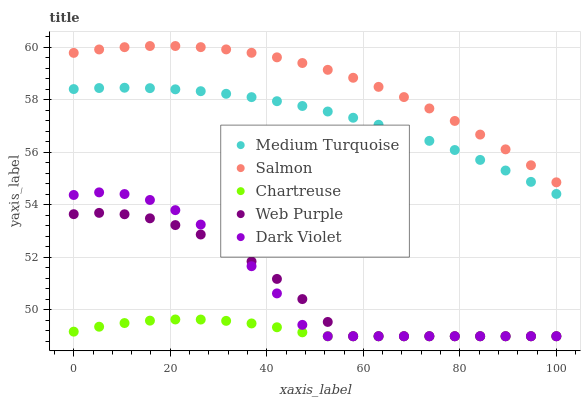Does Chartreuse have the minimum area under the curve?
Answer yes or no. Yes. Does Salmon have the maximum area under the curve?
Answer yes or no. Yes. Does Salmon have the minimum area under the curve?
Answer yes or no. No. Does Chartreuse have the maximum area under the curve?
Answer yes or no. No. Is Medium Turquoise the smoothest?
Answer yes or no. Yes. Is Dark Violet the roughest?
Answer yes or no. Yes. Is Chartreuse the smoothest?
Answer yes or no. No. Is Chartreuse the roughest?
Answer yes or no. No. Does Dark Violet have the lowest value?
Answer yes or no. Yes. Does Salmon have the lowest value?
Answer yes or no. No. Does Salmon have the highest value?
Answer yes or no. Yes. Does Chartreuse have the highest value?
Answer yes or no. No. Is Chartreuse less than Salmon?
Answer yes or no. Yes. Is Salmon greater than Web Purple?
Answer yes or no. Yes. Does Web Purple intersect Dark Violet?
Answer yes or no. Yes. Is Web Purple less than Dark Violet?
Answer yes or no. No. Is Web Purple greater than Dark Violet?
Answer yes or no. No. Does Chartreuse intersect Salmon?
Answer yes or no. No. 